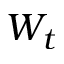Convert formula to latex. <formula><loc_0><loc_0><loc_500><loc_500>W _ { t }</formula> 